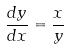<formula> <loc_0><loc_0><loc_500><loc_500>\frac { d y } { d x } = \frac { x } { y }</formula> 